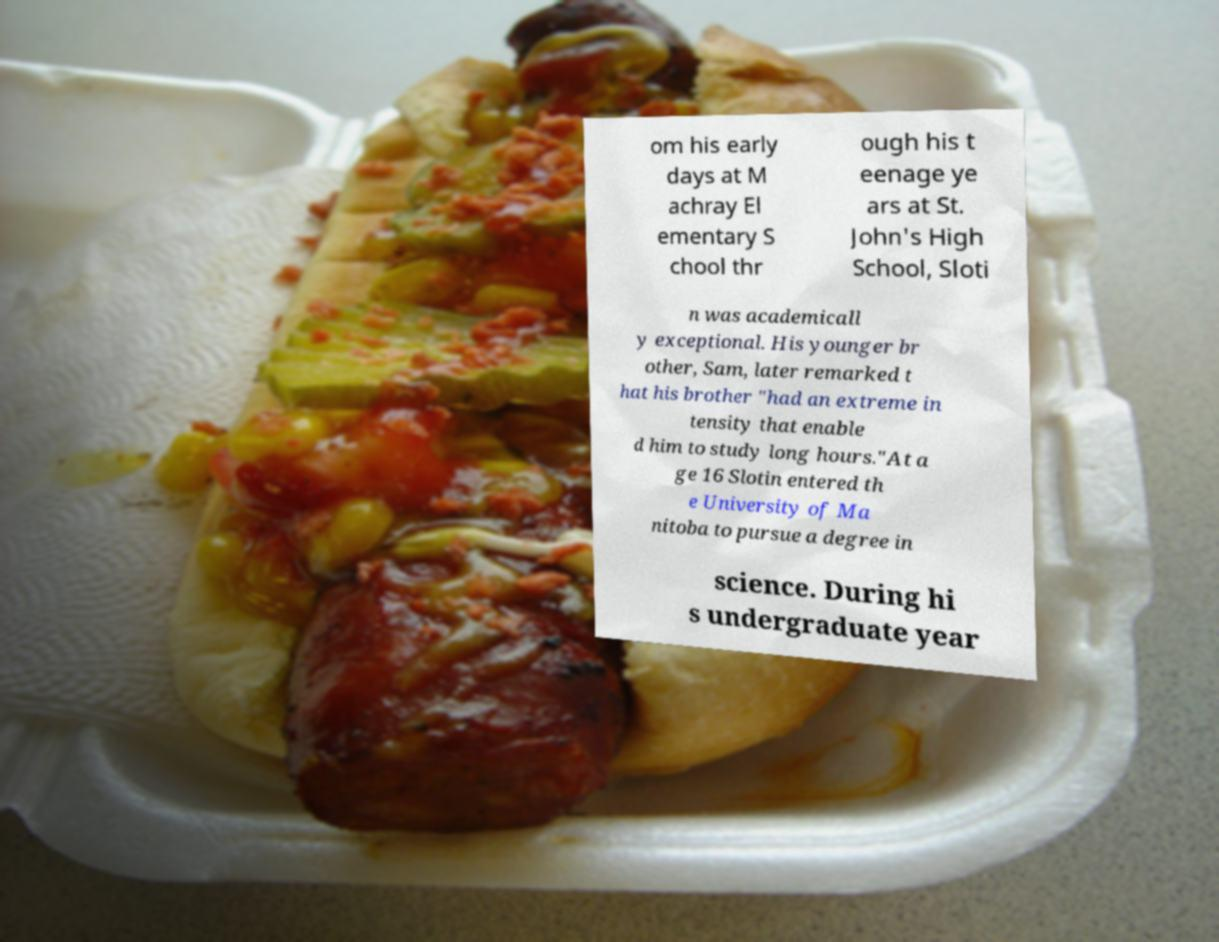Could you assist in decoding the text presented in this image and type it out clearly? om his early days at M achray El ementary S chool thr ough his t eenage ye ars at St. John's High School, Sloti n was academicall y exceptional. His younger br other, Sam, later remarked t hat his brother "had an extreme in tensity that enable d him to study long hours."At a ge 16 Slotin entered th e University of Ma nitoba to pursue a degree in science. During hi s undergraduate year 